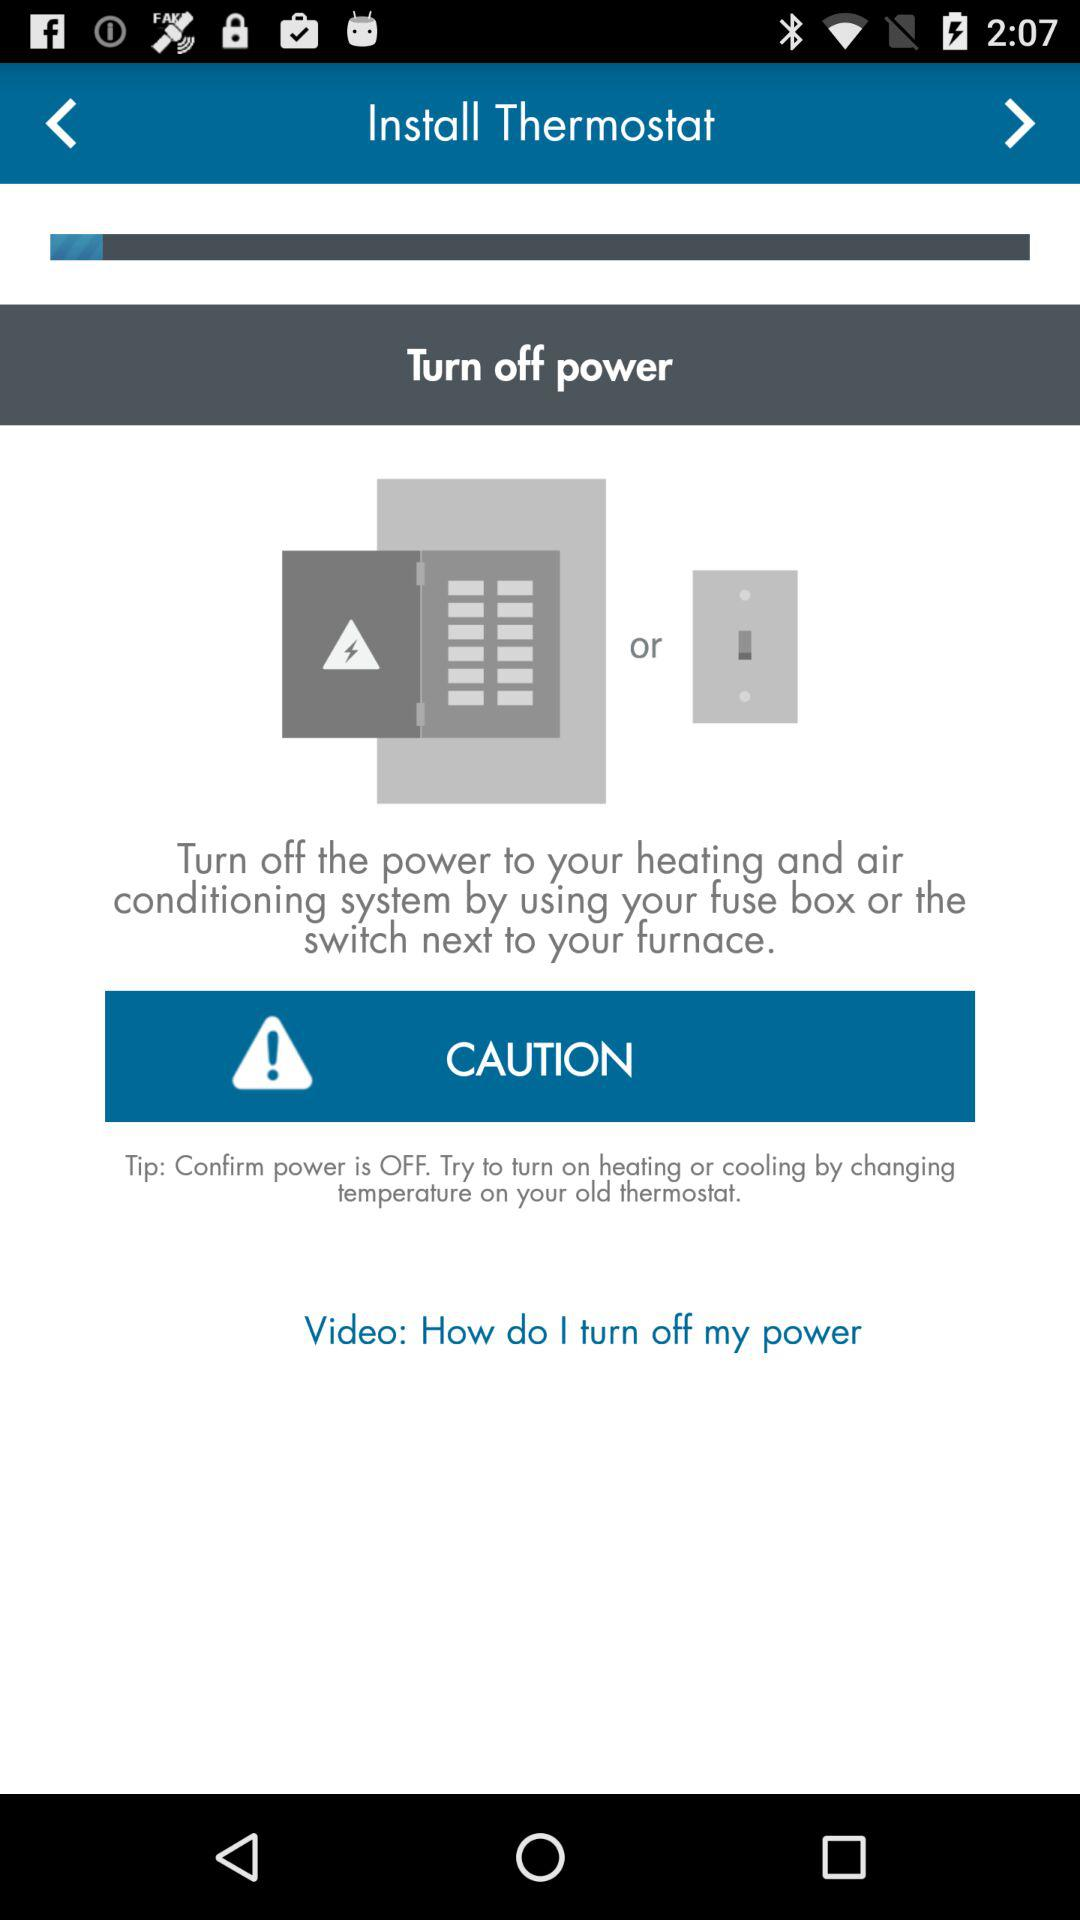What is the name of the application?
When the provided information is insufficient, respond with <no answer>. <no answer> 